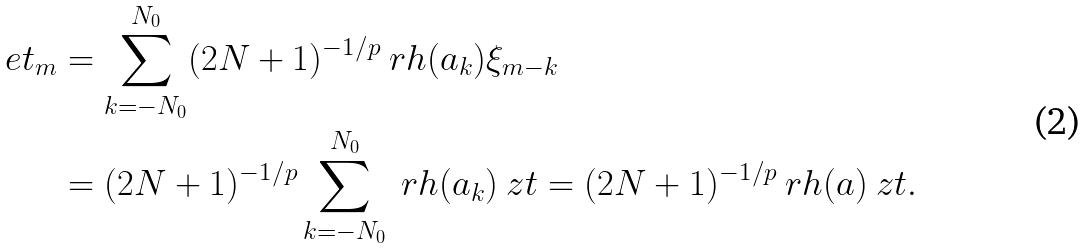<formula> <loc_0><loc_0><loc_500><loc_500>\ e t _ { m } & = \sum _ { k = - N _ { 0 } } ^ { N _ { 0 } } ( 2 N + 1 ) ^ { - 1 / p } \ r h ( a _ { k } ) \xi _ { m - k } \\ & = ( 2 N + 1 ) ^ { - 1 / p } \sum _ { k = - N _ { 0 } } ^ { N _ { 0 } } \ r h ( a _ { k } ) \ z t = ( 2 N + 1 ) ^ { - 1 / p } \ r h ( a ) \ z t .</formula> 